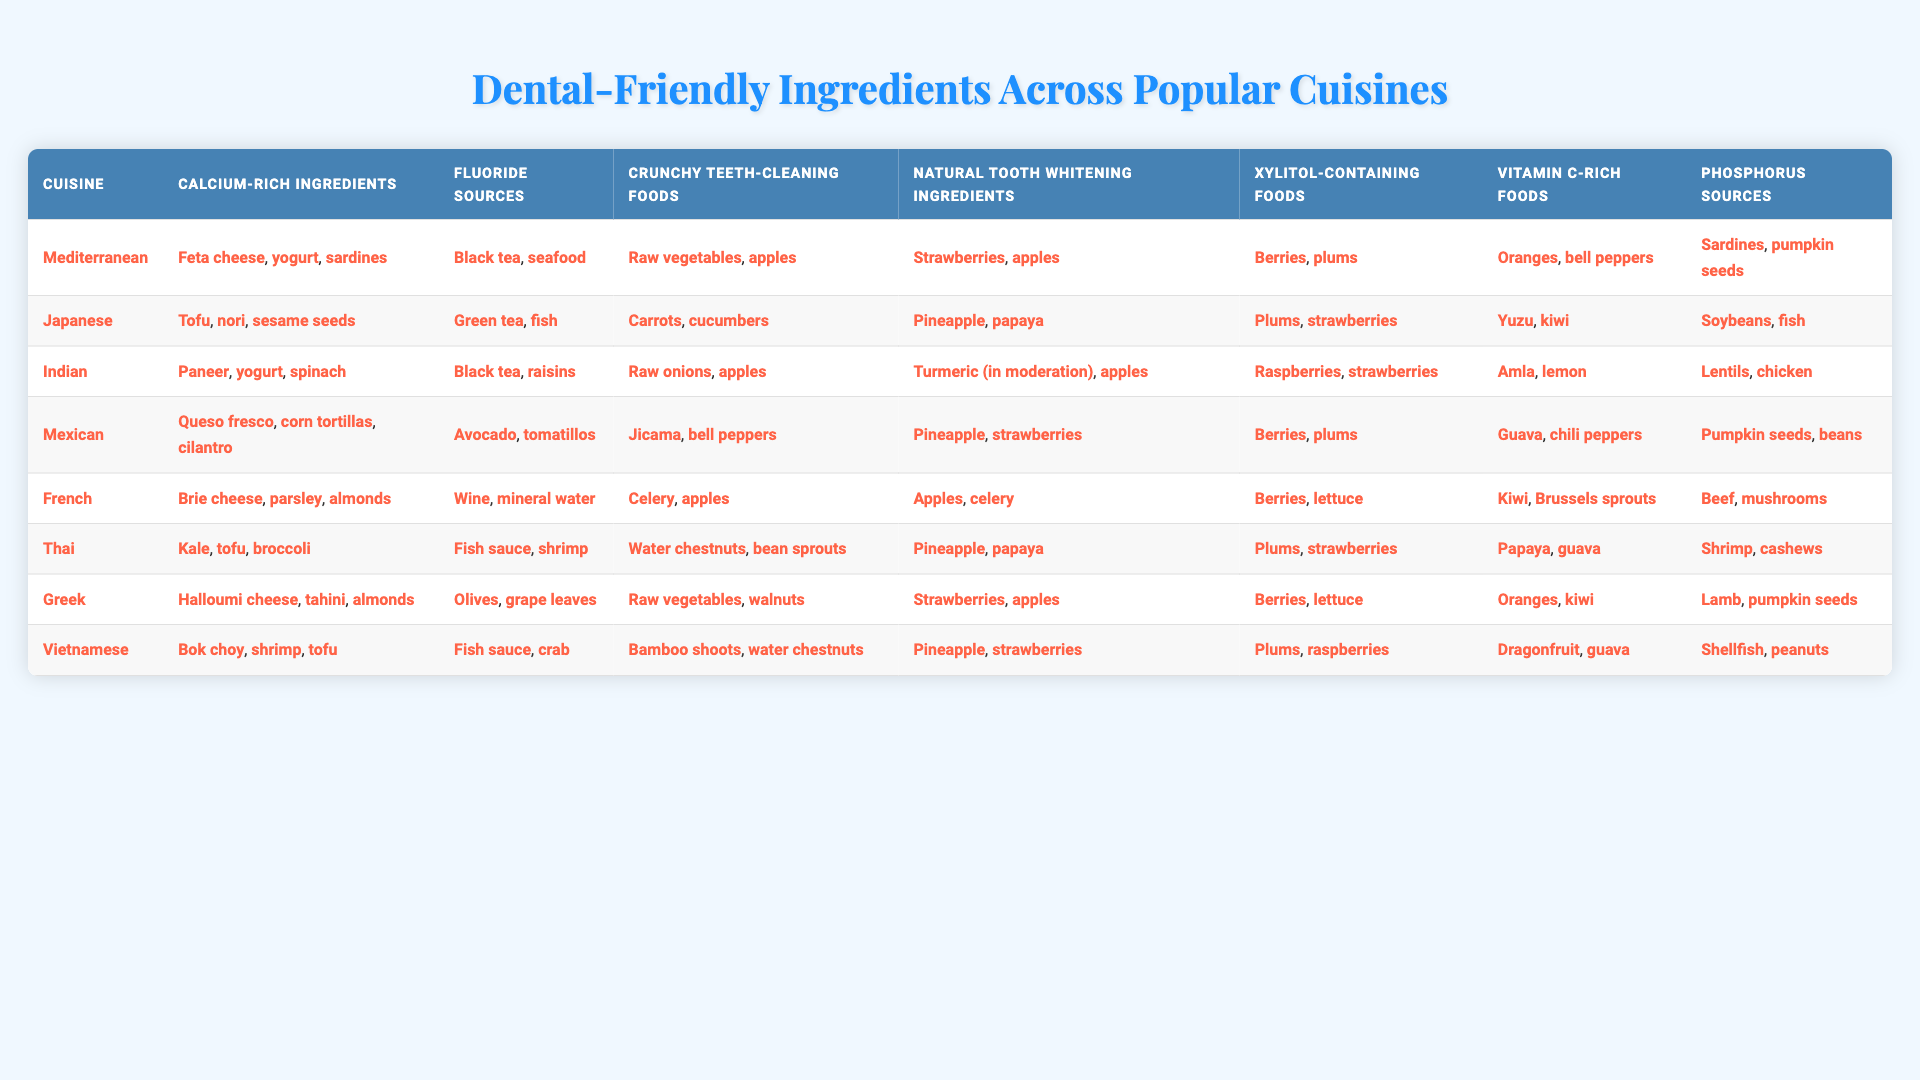What are the calcium-rich ingredients in Japanese cuisine? The table indicates that Japanese cuisine includes tofu, nori, and sesame seeds as calcium-rich ingredients.
Answer: Tofu, nori, sesame seeds Which cuisine has natural tooth whitening ingredients that include turmeric? According to the table, Indian cuisine is listed with turmeric in its natural tooth whitening ingredients.
Answer: Indian cuisine Is broccoli a calcium-rich ingredient in Thai cuisine? The table shows that in Thai cuisine, the calcium-rich ingredients are kale, tofu, and broccoli, so yes, broccoli is included.
Answer: Yes What are the xylitol-containing foods for Mediterranean cuisine? The table specifies that Mediterranean cuisine includes berries and plums as xylitol-containing foods.
Answer: Berries, plums Which cuisine has both pineapple and strawberries in its natural tooth whitening ingredients? The table shows that both Thai and Mexican cuisines include pineapple and strawberries in their natural tooth whitening ingredients.
Answer: Thai and Mexican cuisines What is the total number of fluoride sources across all cuisines listed? By counting the fluoride sources listed in each cuisine: 1 (Mediterranean) + 1 (Japanese) + 1 (Indian) + 1 (Mexican) + 1 (French) + 1 (Thai) + 1 (Greek) + 1 (Vietnamese) = 8 total fluoride sources.
Answer: 8 Which cuisine features the highest variety of phosphorus sources? On checking the phosphorus sources, Greek cuisine presents lamb and pumpkin seeds, while Vietnamese cuisine lists shellfish and peanuts, both having similar varieties. However, some cuisines have only one or two, making Greek and Vietnamese cuisines stand out.
Answer: Greek and Vietnamese cuisines Which cuisine has no sources of xylitol and also features raw apples as crunchy teeth-cleaning food? The data indicates that French cuisine contains no listed xylitol-containing foods, and it includes celery and apples as crunchy teeth-cleaning foods. Thus, French cuisine meets both criteria.
Answer: French cuisine What can be concluded about the presence of vitamin C-rich foods among Mediterranean and Thai cuisines? Both Mediterranean and Thai cuisines include vitamin C-rich foods (Oranges and bell peppers for Mediterranean; Papaya and guava for Thai), hence both have vitamin C-rich foods listed.
Answer: Both cuisines have vitamin C-rich foods Are there any cuisines that include both chloride sources and phosphorus sources? Upon review, Mediterranean, Indian, and Greek cuisines have phosphorus sources, but none mention chloride sources. Thus, there's no overlap.
Answer: No cuisines have both 